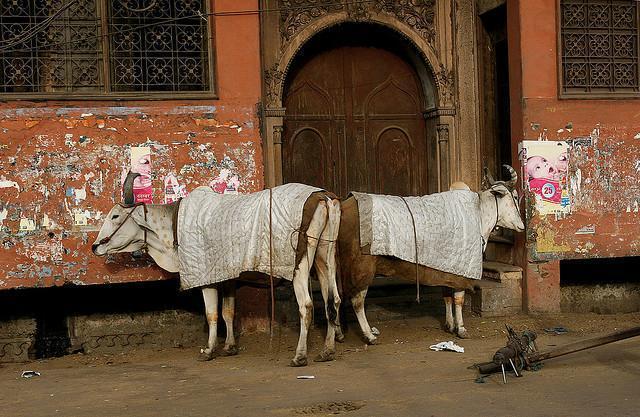How many cows are there?
Give a very brief answer. 2. How many people are stooping in the picture?
Give a very brief answer. 0. 